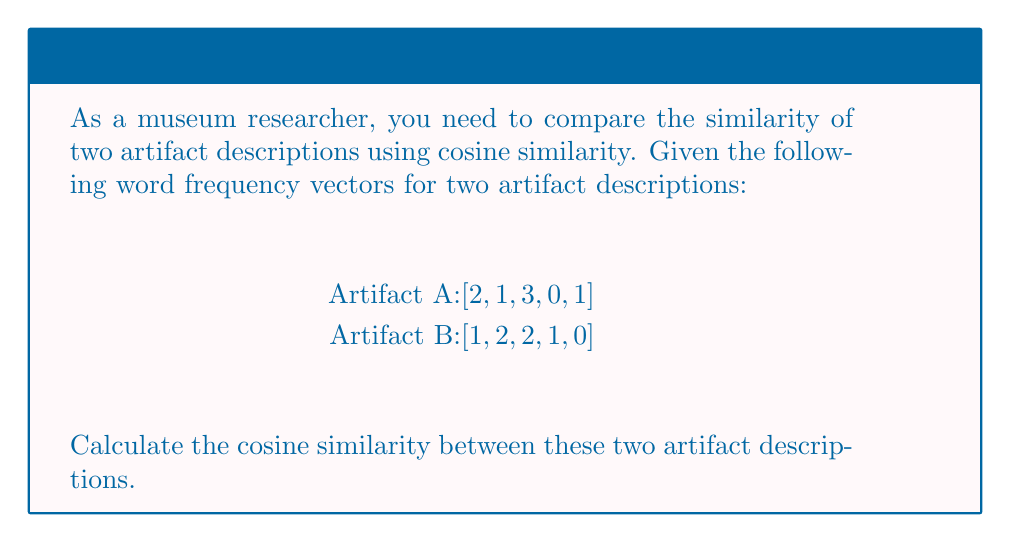Can you solve this math problem? To calculate the cosine similarity between two vectors, we use the formula:

$$ \text{Cosine Similarity} = \frac{\mathbf{A} \cdot \mathbf{B}}{\|\mathbf{A}\| \|\mathbf{B}\|} $$

Where $\mathbf{A} \cdot \mathbf{B}$ is the dot product of the vectors, and $\|\mathbf{A}\|$ and $\|\mathbf{B}\|$ are the magnitudes of vectors A and B respectively.

Step 1: Calculate the dot product $\mathbf{A} \cdot \mathbf{B}$
$\mathbf{A} \cdot \mathbf{B} = (2 \times 1) + (1 \times 2) + (3 \times 2) + (0 \times 1) + (1 \times 0) = 2 + 2 + 6 + 0 + 0 = 10$

Step 2: Calculate the magnitude of vector A
$\|\mathbf{A}\| = \sqrt{2^2 + 1^2 + 3^2 + 0^2 + 1^2} = \sqrt{4 + 1 + 9 + 0 + 1} = \sqrt{15}$

Step 3: Calculate the magnitude of vector B
$\|\mathbf{B}\| = \sqrt{1^2 + 2^2 + 2^2 + 1^2 + 0^2} = \sqrt{1 + 4 + 4 + 1 + 0} = \sqrt{10}$

Step 4: Apply the cosine similarity formula
$$ \text{Cosine Similarity} = \frac{10}{\sqrt{15} \times \sqrt{10}} = \frac{10}{\sqrt{150}} $$

Step 5: Simplify the result
$$ \text{Cosine Similarity} = \frac{10}{\sqrt{150}} \approx 0.8165 $$
Answer: $0.8165$ 